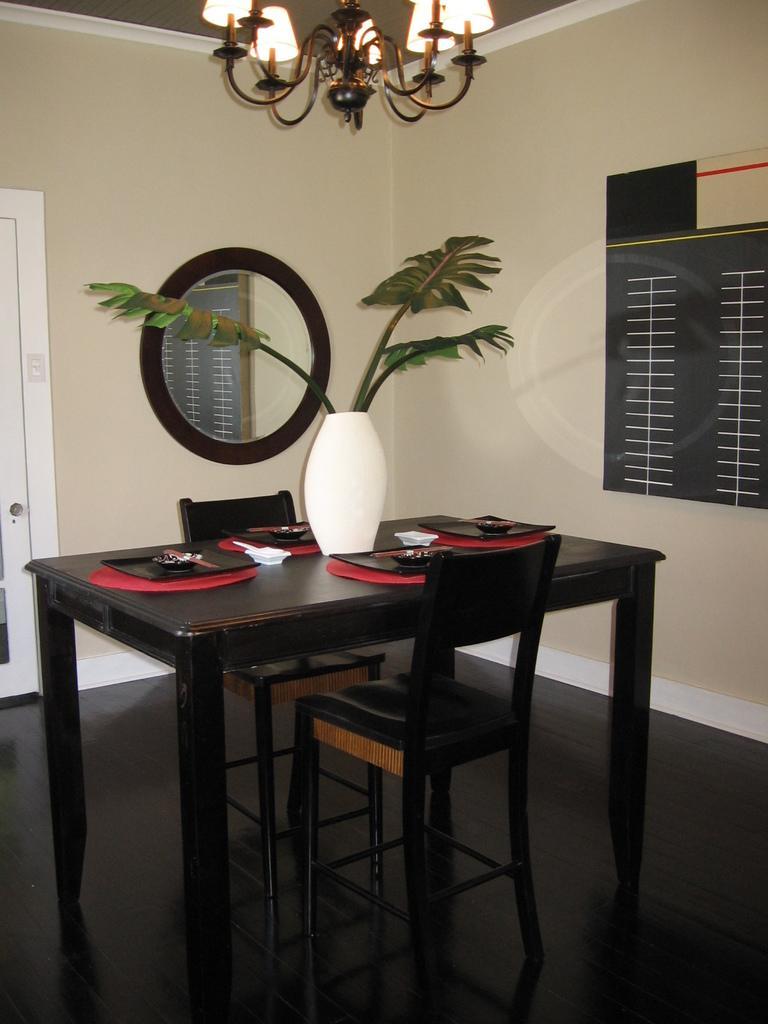Can you describe this image briefly? In this image their is a table on which there is a flower vase,plates and a small plate on it. Beside the table there are two chairs. In the background there is a mirror and the door. At the top there is a chandelier. 